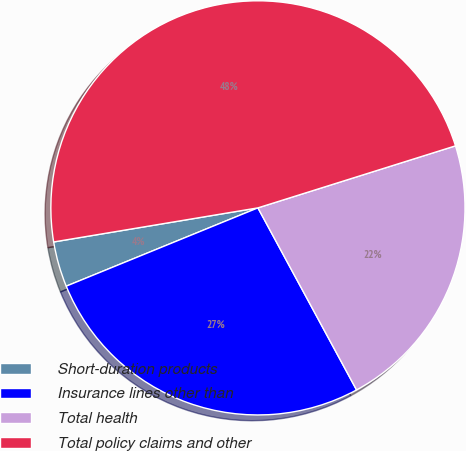Convert chart to OTSL. <chart><loc_0><loc_0><loc_500><loc_500><pie_chart><fcel>Short-duration products<fcel>Insurance lines other than<fcel>Total health<fcel>Total policy claims and other<nl><fcel>3.54%<fcel>26.73%<fcel>21.94%<fcel>47.79%<nl></chart> 